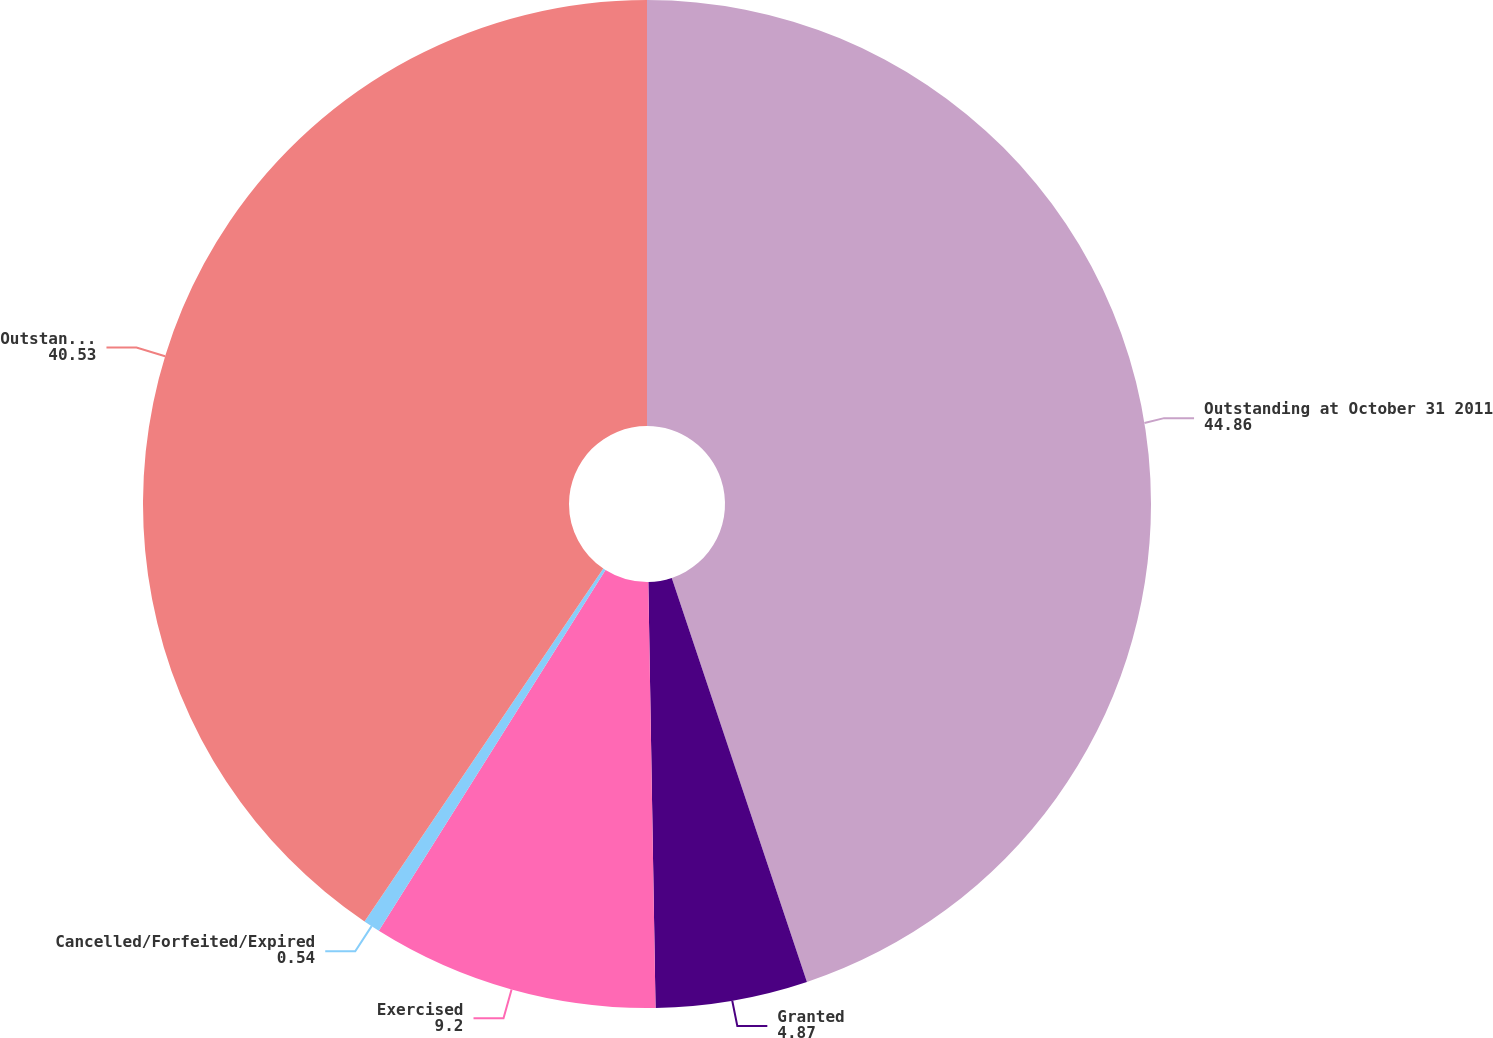Convert chart to OTSL. <chart><loc_0><loc_0><loc_500><loc_500><pie_chart><fcel>Outstanding at October 31 2011<fcel>Granted<fcel>Exercised<fcel>Cancelled/Forfeited/Expired<fcel>Outstanding at October 31 2012<nl><fcel>44.86%<fcel>4.87%<fcel>9.2%<fcel>0.54%<fcel>40.53%<nl></chart> 